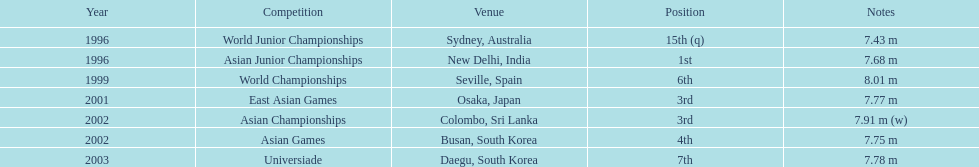Parse the full table. {'header': ['Year', 'Competition', 'Venue', 'Position', 'Notes'], 'rows': [['1996', 'World Junior Championships', 'Sydney, Australia', '15th (q)', '7.43 m'], ['1996', 'Asian Junior Championships', 'New Delhi, India', '1st', '7.68 m'], ['1999', 'World Championships', 'Seville, Spain', '6th', '8.01 m'], ['2001', 'East Asian Games', 'Osaka, Japan', '3rd', '7.77 m'], ['2002', 'Asian Championships', 'Colombo, Sri Lanka', '3rd', '7.91 m (w)'], ['2002', 'Asian Games', 'Busan, South Korea', '4th', '7.75 m'], ['2003', 'Universiade', 'Daegu, South Korea', '7th', '7.78 m']]} In which year was his most impressive jump? 1999. 